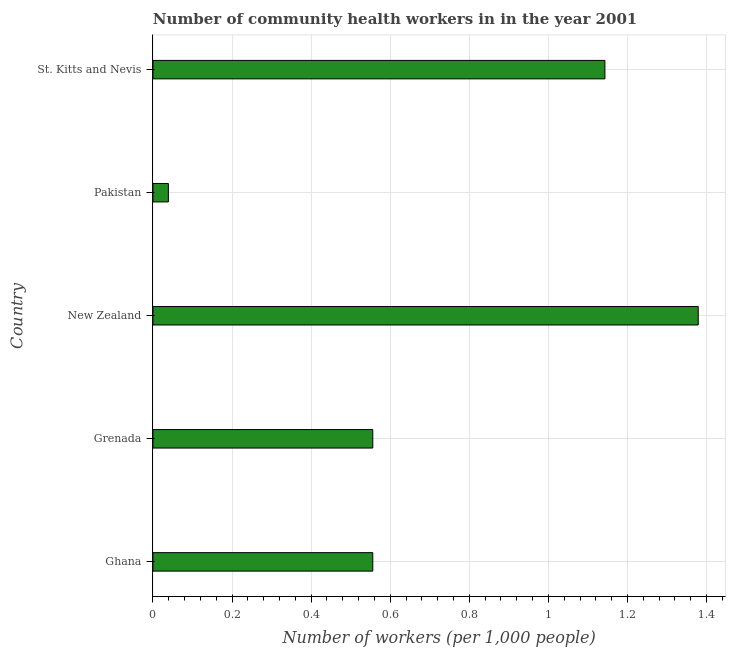What is the title of the graph?
Give a very brief answer. Number of community health workers in in the year 2001. What is the label or title of the X-axis?
Ensure brevity in your answer.  Number of workers (per 1,0 people). What is the number of community health workers in New Zealand?
Make the answer very short. 1.38. Across all countries, what is the maximum number of community health workers?
Your answer should be very brief. 1.38. Across all countries, what is the minimum number of community health workers?
Your response must be concise. 0.04. In which country was the number of community health workers maximum?
Make the answer very short. New Zealand. What is the sum of the number of community health workers?
Your answer should be compact. 3.67. What is the difference between the number of community health workers in Ghana and St. Kitts and Nevis?
Provide a short and direct response. -0.59. What is the average number of community health workers per country?
Make the answer very short. 0.73. What is the median number of community health workers?
Ensure brevity in your answer.  0.56. In how many countries, is the number of community health workers greater than 0.2 ?
Your response must be concise. 4. What is the ratio of the number of community health workers in Ghana to that in St. Kitts and Nevis?
Offer a very short reply. 0.49. Is the number of community health workers in Grenada less than that in St. Kitts and Nevis?
Offer a terse response. Yes. What is the difference between the highest and the second highest number of community health workers?
Your answer should be compact. 0.24. Is the sum of the number of community health workers in Ghana and St. Kitts and Nevis greater than the maximum number of community health workers across all countries?
Give a very brief answer. Yes. What is the difference between the highest and the lowest number of community health workers?
Ensure brevity in your answer.  1.34. In how many countries, is the number of community health workers greater than the average number of community health workers taken over all countries?
Your response must be concise. 2. What is the difference between two consecutive major ticks on the X-axis?
Make the answer very short. 0.2. Are the values on the major ticks of X-axis written in scientific E-notation?
Your response must be concise. No. What is the Number of workers (per 1,000 people) in Ghana?
Your answer should be very brief. 0.56. What is the Number of workers (per 1,000 people) in Grenada?
Make the answer very short. 0.56. What is the Number of workers (per 1,000 people) of New Zealand?
Make the answer very short. 1.38. What is the Number of workers (per 1,000 people) of Pakistan?
Keep it short and to the point. 0.04. What is the Number of workers (per 1,000 people) of St. Kitts and Nevis?
Offer a terse response. 1.14. What is the difference between the Number of workers (per 1,000 people) in Ghana and New Zealand?
Ensure brevity in your answer.  -0.82. What is the difference between the Number of workers (per 1,000 people) in Ghana and Pakistan?
Keep it short and to the point. 0.52. What is the difference between the Number of workers (per 1,000 people) in Ghana and St. Kitts and Nevis?
Ensure brevity in your answer.  -0.59. What is the difference between the Number of workers (per 1,000 people) in Grenada and New Zealand?
Your answer should be very brief. -0.82. What is the difference between the Number of workers (per 1,000 people) in Grenada and Pakistan?
Give a very brief answer. 0.52. What is the difference between the Number of workers (per 1,000 people) in Grenada and St. Kitts and Nevis?
Ensure brevity in your answer.  -0.59. What is the difference between the Number of workers (per 1,000 people) in New Zealand and Pakistan?
Your response must be concise. 1.34. What is the difference between the Number of workers (per 1,000 people) in New Zealand and St. Kitts and Nevis?
Your answer should be compact. 0.24. What is the difference between the Number of workers (per 1,000 people) in Pakistan and St. Kitts and Nevis?
Give a very brief answer. -1.1. What is the ratio of the Number of workers (per 1,000 people) in Ghana to that in New Zealand?
Provide a succinct answer. 0.4. What is the ratio of the Number of workers (per 1,000 people) in Ghana to that in Pakistan?
Your answer should be compact. 14.26. What is the ratio of the Number of workers (per 1,000 people) in Ghana to that in St. Kitts and Nevis?
Make the answer very short. 0.49. What is the ratio of the Number of workers (per 1,000 people) in Grenada to that in New Zealand?
Your response must be concise. 0.4. What is the ratio of the Number of workers (per 1,000 people) in Grenada to that in Pakistan?
Ensure brevity in your answer.  14.26. What is the ratio of the Number of workers (per 1,000 people) in Grenada to that in St. Kitts and Nevis?
Make the answer very short. 0.49. What is the ratio of the Number of workers (per 1,000 people) in New Zealand to that in Pakistan?
Provide a short and direct response. 35.36. What is the ratio of the Number of workers (per 1,000 people) in New Zealand to that in St. Kitts and Nevis?
Your answer should be very brief. 1.21. What is the ratio of the Number of workers (per 1,000 people) in Pakistan to that in St. Kitts and Nevis?
Offer a very short reply. 0.03. 